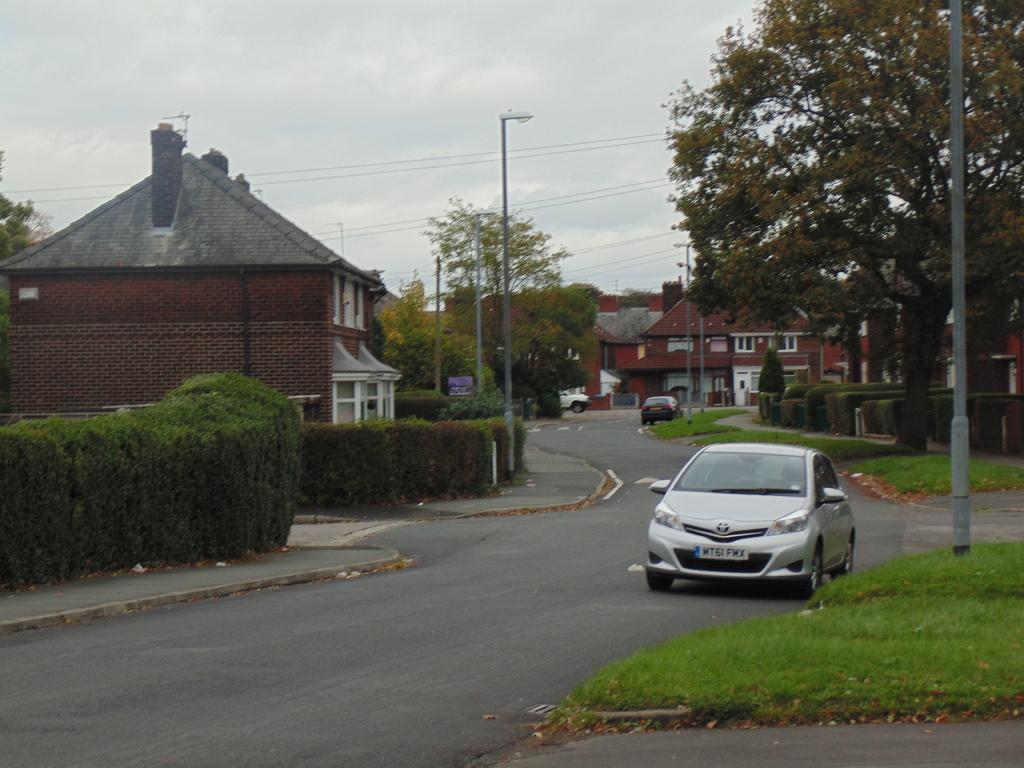Can you describe this image briefly? In this image, I can see the cars on the road. On the right side of the image, It looks like the grass. These are the trees and bushes, which are beside the road. I can see the buildings with the windows. At the top of the image, I can see the sky. I think these are the street lights. 